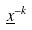Convert formula to latex. <formula><loc_0><loc_0><loc_500><loc_500>\underline { x } ^ { - k }</formula> 